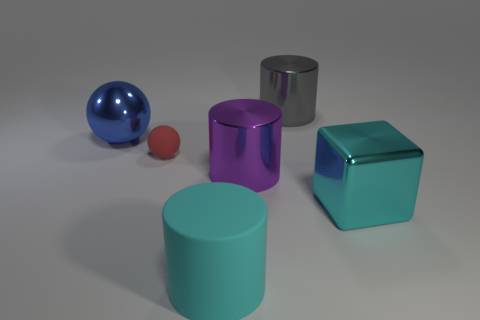Can you tell me the different colors visible in this image? Certainly! The image depicts several objects of different colors: a metallic silver cylinder, a purple translucent cube, a cyan cylinder, a red sphere, and a blue sphere. 